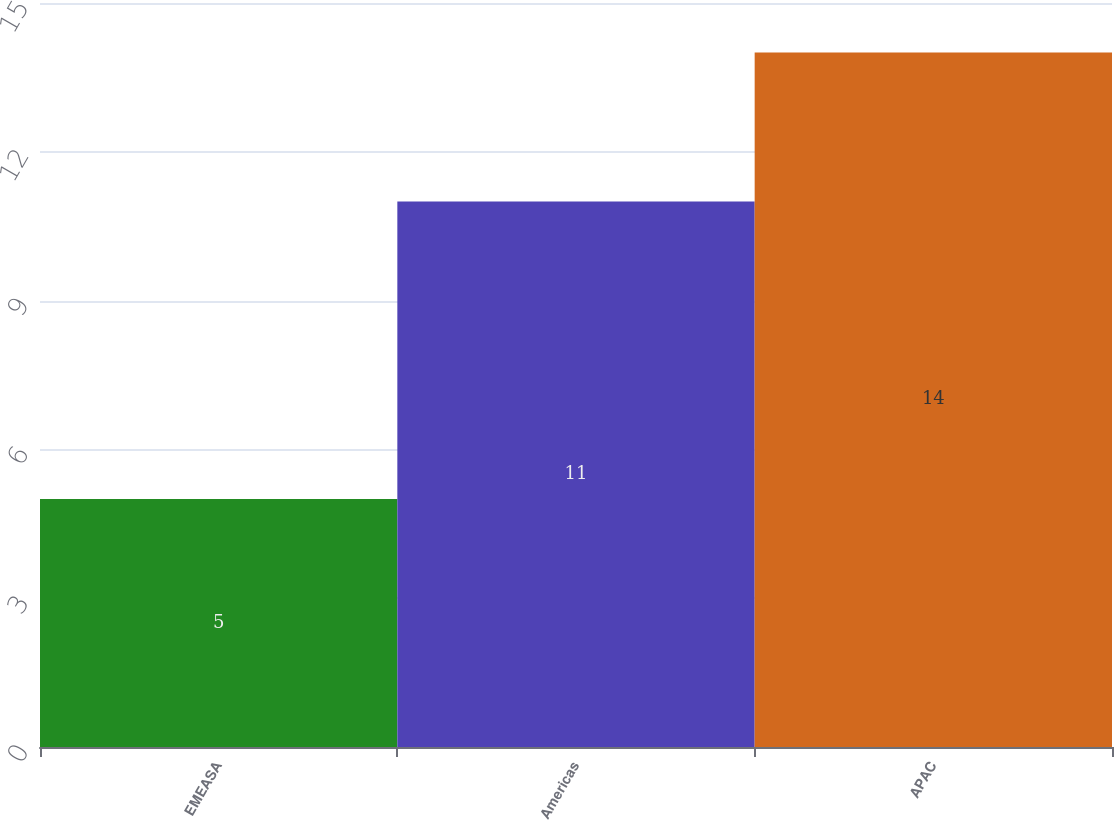Convert chart to OTSL. <chart><loc_0><loc_0><loc_500><loc_500><bar_chart><fcel>EMEASA<fcel>Americas<fcel>APAC<nl><fcel>5<fcel>11<fcel>14<nl></chart> 